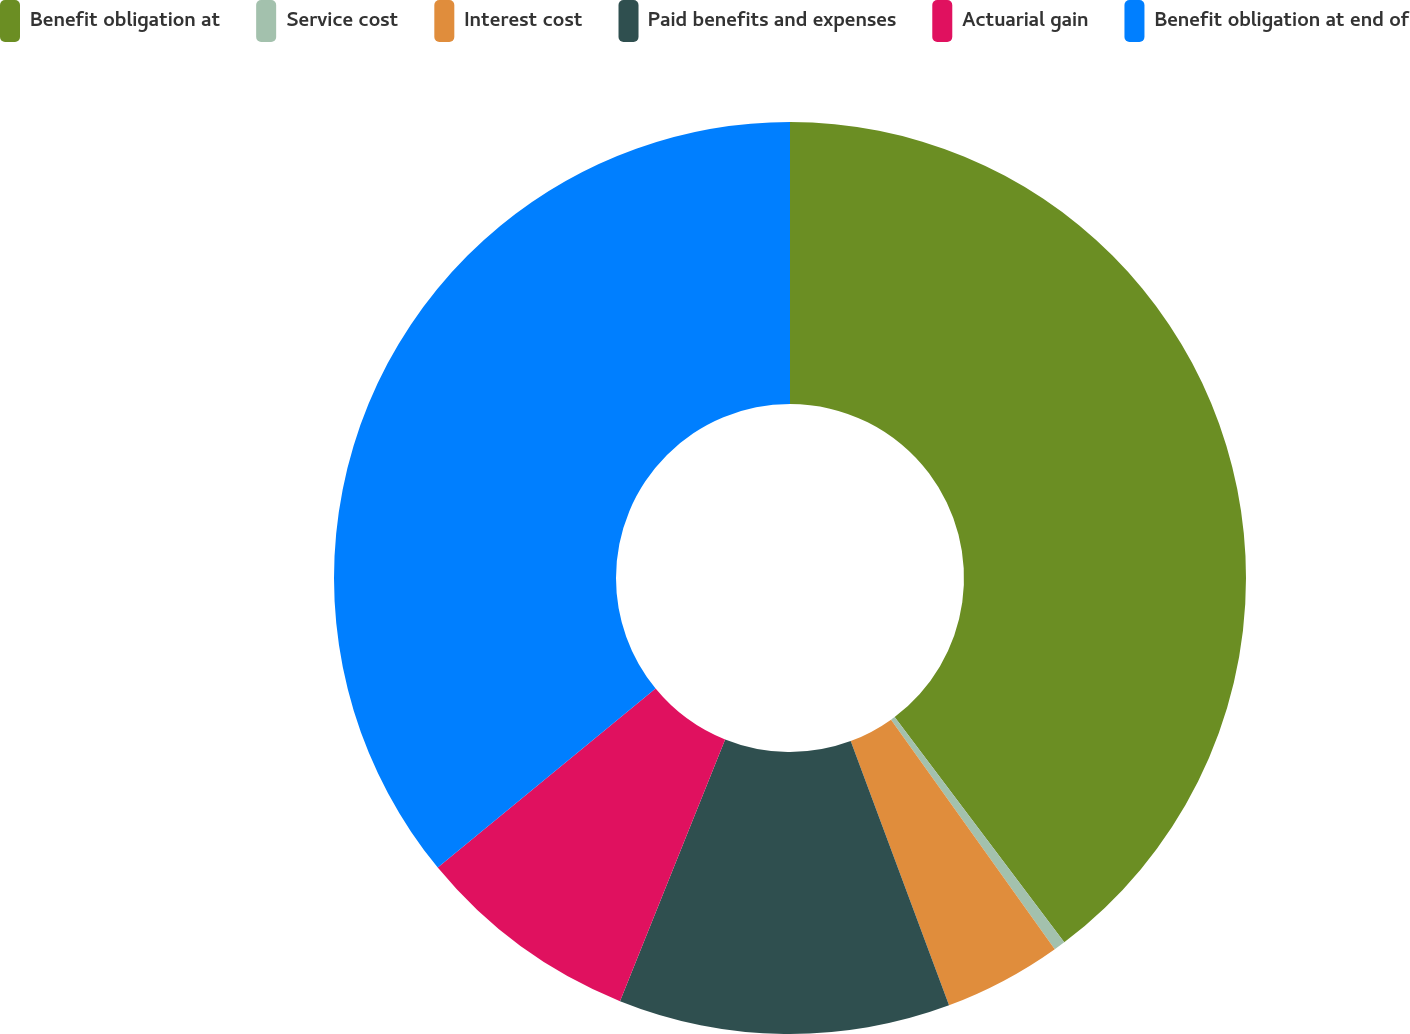Convert chart. <chart><loc_0><loc_0><loc_500><loc_500><pie_chart><fcel>Benefit obligation at<fcel>Service cost<fcel>Interest cost<fcel>Paid benefits and expenses<fcel>Actuarial gain<fcel>Benefit obligation at end of<nl><fcel>39.73%<fcel>0.41%<fcel>4.19%<fcel>11.75%<fcel>7.97%<fcel>35.95%<nl></chart> 